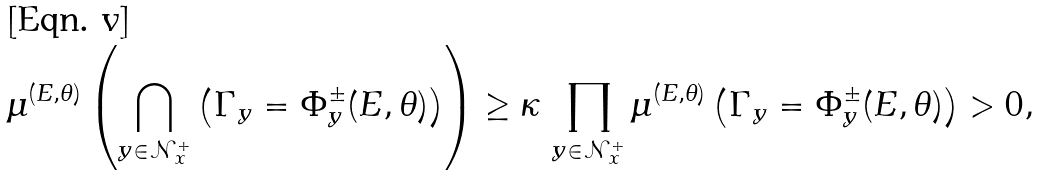Convert formula to latex. <formula><loc_0><loc_0><loc_500><loc_500>\mu ^ { ( E , \theta ) } \left ( \bigcap _ { y \in \mathcal { N } _ { x } ^ { + } } \left ( \Gamma _ { y } = \Phi _ { y } ^ { \pm } ( E , \theta ) \right ) \right ) \geq \kappa \, \prod _ { y \in \mathcal { N } _ { x } ^ { + } } \mu ^ { ( E , \theta ) } \left ( \Gamma _ { y } = \Phi _ { y } ^ { \pm } ( E , \theta ) \right ) > 0 ,</formula> 